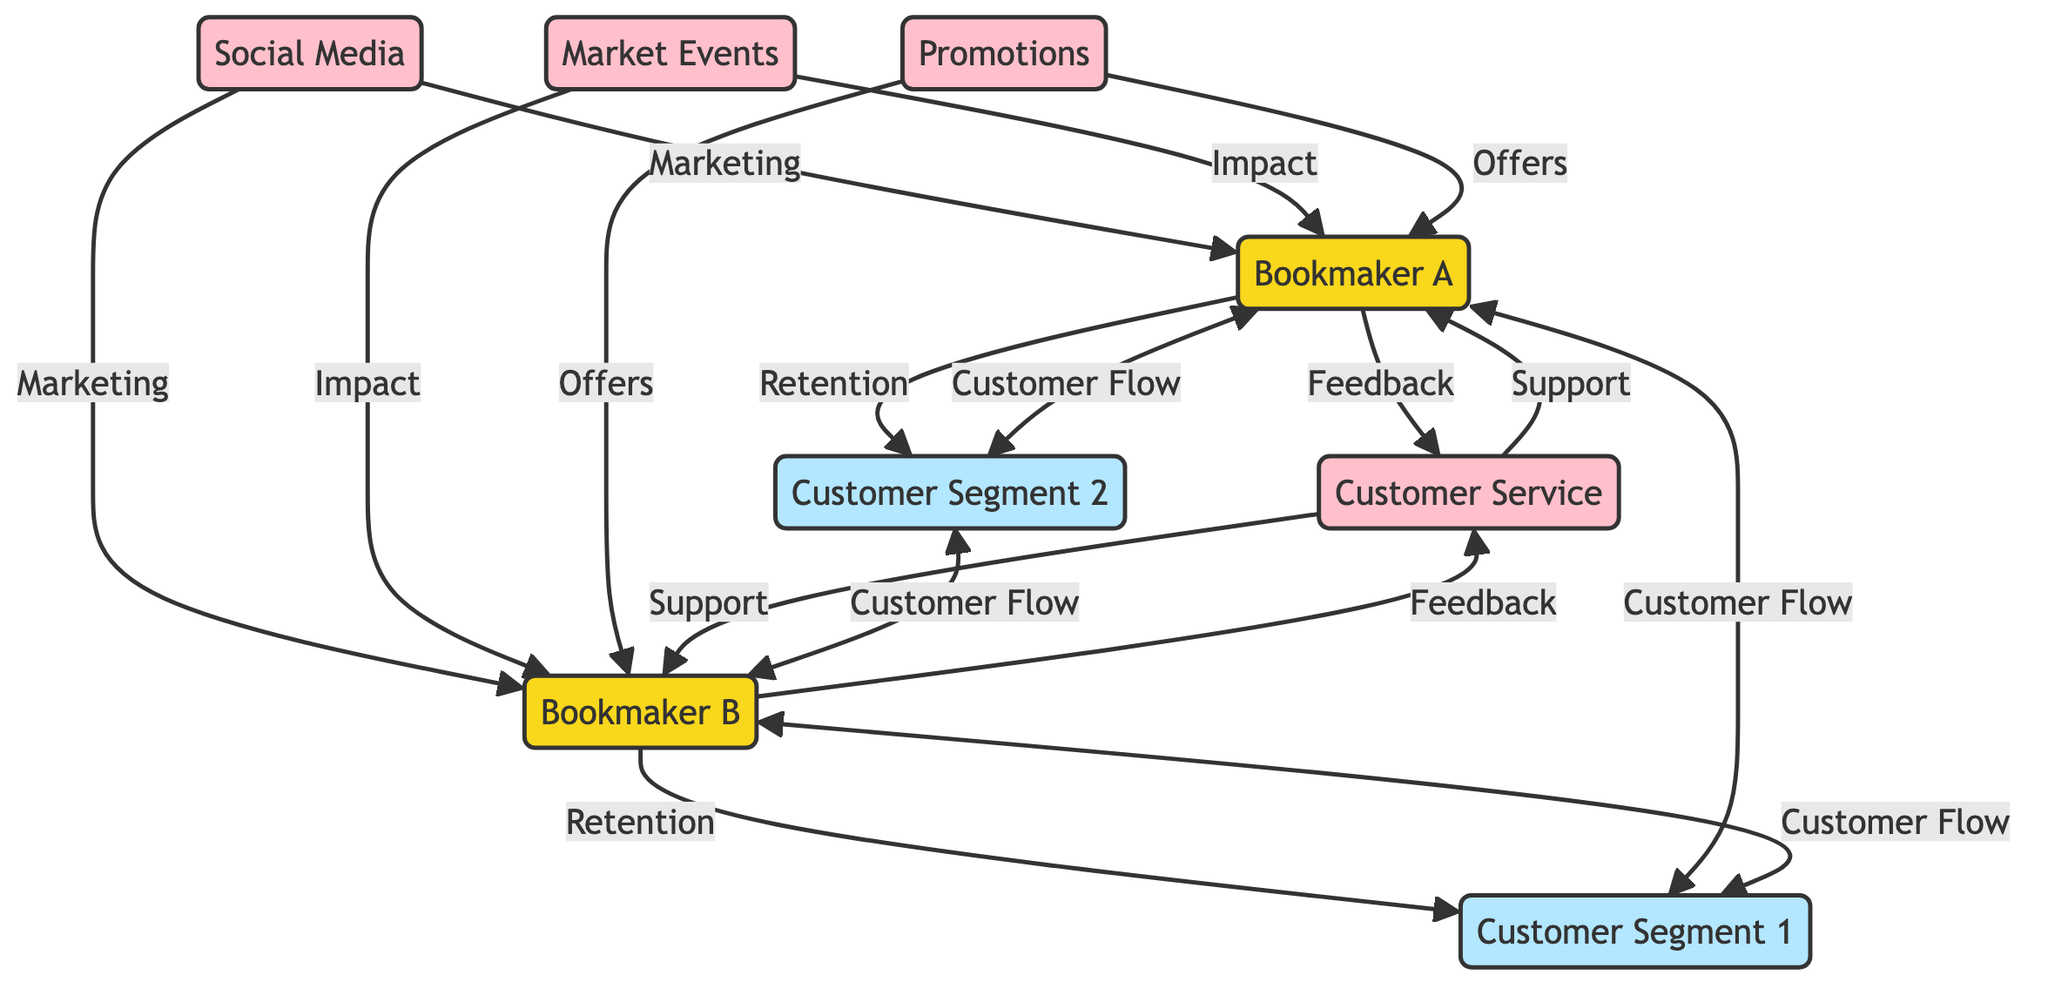What are the two bookmakers in the diagram? The diagram shows two nodes labeled "Bookmaker A" and "Bookmaker B," which are clearly indicated and represent the competing bookmakers in the market.
Answer: Bookmaker A, Bookmaker B How many external influences are depicted in the diagram? The diagram lists three nodes classified as external: "Social Media," "Market Events," and "Promotions." Counting these nodes gives a total of three external influences.
Answer: 3 Which customer segment is linked to Bookmaker A by Customer Flow? The diagram shows that "Customer Segment 1" (Customer1) and "Customer Segment 2" (Customer2) both connect to "Bookmaker A" through "Customer Flow", making "Customer Segment 1" a direct link.
Answer: Customer Segment 1 What type of relationship is shown between Bookmaker B and Customer Segment 1? The diagram displays a "Retention" relationship flowing from "Bookmaker B" to "Customer Segment 1," indicating that "Bookmaker B" attempts to retain this customer segment.
Answer: Retention How many total customer flow connections are depicted in the diagram? The diagram shows four customer flow connections: Customer1 to Bookmaker A, Customer1 to Bookmaker B, Customer2 to Bookmaker A, and Customer2 to Bookmaker B. Counting these provides a total of four connections.
Answer: 4 What are the two main types of support provided by Customer Service to the bookmakers? The diagram illustrates that "Customer Service" provides "Support" to both "Bookmaker A" and "Bookmaker B" in parallel connection lines, indicating that both receive the same type of support.
Answer: Support Which external influence connects Marketing to both bookmakers? "Social Media" is the external influence clearly labeled as providing "Marketing" to both "Bookmaker A" and "Bookmaker B," indicating its role in promoting both.
Answer: Social Media Which customer segment is retained by Bookmaker A? The diagram shows a "Retention" relationship flowing from "Bookmaker A" to "Customer Segment 2," indicating that this particular customer segment is a focus for retention efforts.
Answer: Customer Segment 2 